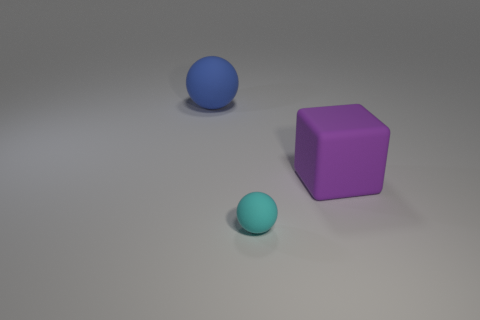What size is the blue thing that is the same shape as the tiny cyan thing?
Your answer should be compact. Large. What number of yellow things are rubber cubes or large matte things?
Give a very brief answer. 0. What number of cyan balls are on the right side of the matte sphere behind the big matte block?
Make the answer very short. 1. How many other objects are there of the same shape as the purple object?
Keep it short and to the point. 0. What is the color of the cube that is the same material as the blue sphere?
Keep it short and to the point. Purple. Is there a cyan object of the same size as the cyan matte ball?
Offer a very short reply. No. Is the number of things that are left of the blue matte object greater than the number of blue spheres that are in front of the big purple matte object?
Your answer should be compact. No. Does the thing right of the cyan matte thing have the same material as the ball that is in front of the blue sphere?
Provide a short and direct response. Yes. The blue object that is the same size as the purple rubber block is what shape?
Offer a terse response. Sphere. Is there another big blue rubber object that has the same shape as the blue object?
Give a very brief answer. No. 